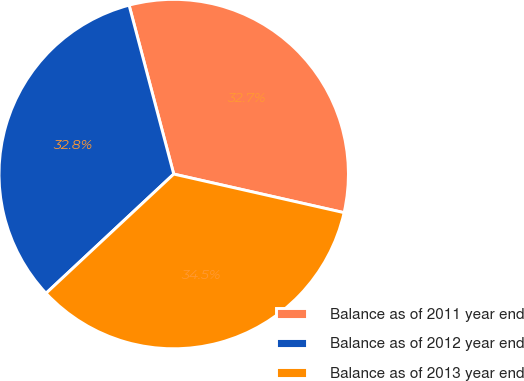<chart> <loc_0><loc_0><loc_500><loc_500><pie_chart><fcel>Balance as of 2011 year end<fcel>Balance as of 2012 year end<fcel>Balance as of 2013 year end<nl><fcel>32.66%<fcel>32.84%<fcel>34.5%<nl></chart> 